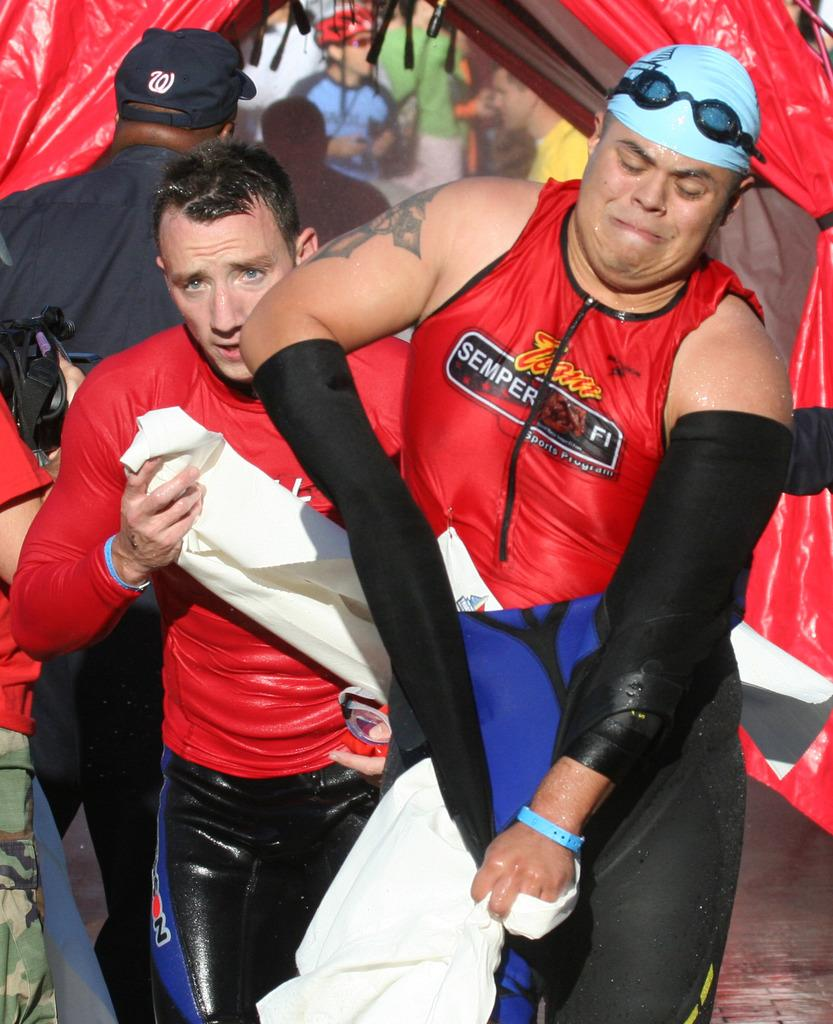<image>
Summarize the visual content of the image. two men in red tops, one reading semper fi 